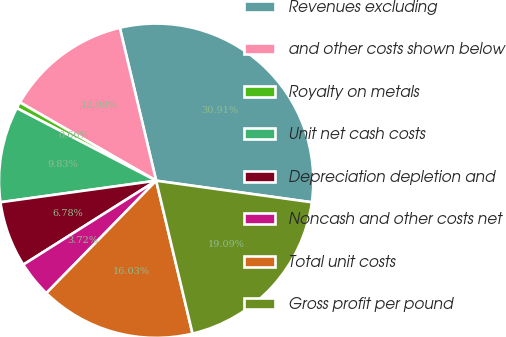Convert chart to OTSL. <chart><loc_0><loc_0><loc_500><loc_500><pie_chart><fcel>Revenues excluding<fcel>and other costs shown below<fcel>Royalty on metals<fcel>Unit net cash costs<fcel>Depreciation depletion and<fcel>Noncash and other costs net<fcel>Total unit costs<fcel>Gross profit per pound<nl><fcel>30.91%<fcel>12.98%<fcel>0.66%<fcel>9.83%<fcel>6.78%<fcel>3.72%<fcel>16.03%<fcel>19.09%<nl></chart> 